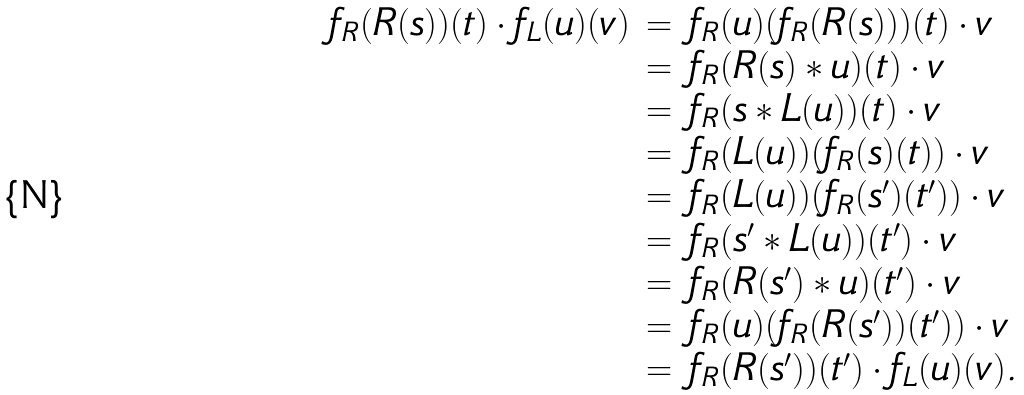Convert formula to latex. <formula><loc_0><loc_0><loc_500><loc_500>\begin{array} { l l l } f _ { R } ( R ( s ) ) ( t ) \cdot f _ { L } ( u ) ( v ) & = & f _ { R } ( u ) ( f _ { R } ( R ( s ) ) ) ( t ) \cdot v \\ & = & f _ { R } ( R ( s ) * u ) ( t ) \cdot v \\ & = & f _ { R } ( s * L ( u ) ) ( t ) \cdot v \\ & = & f _ { R } ( L ( u ) ) ( f _ { R } ( s ) ( t ) ) \cdot v \\ & = & f _ { R } ( L ( u ) ) ( f _ { R } ( s ^ { \prime } ) ( t ^ { \prime } ) ) \cdot v \\ & = & f _ { R } ( s ^ { \prime } * L ( u ) ) ( t ^ { \prime } ) \cdot v \\ & = & f _ { R } ( R ( s ^ { \prime } ) * u ) ( t ^ { \prime } ) \cdot v \\ & = & f _ { R } ( u ) ( f _ { R } ( R ( s ^ { \prime } ) ) ( t ^ { \prime } ) ) \cdot v \\ & = & f _ { R } ( R ( s ^ { \prime } ) ) ( t ^ { \prime } ) \cdot f _ { L } ( u ) ( v ) . \end{array}</formula> 